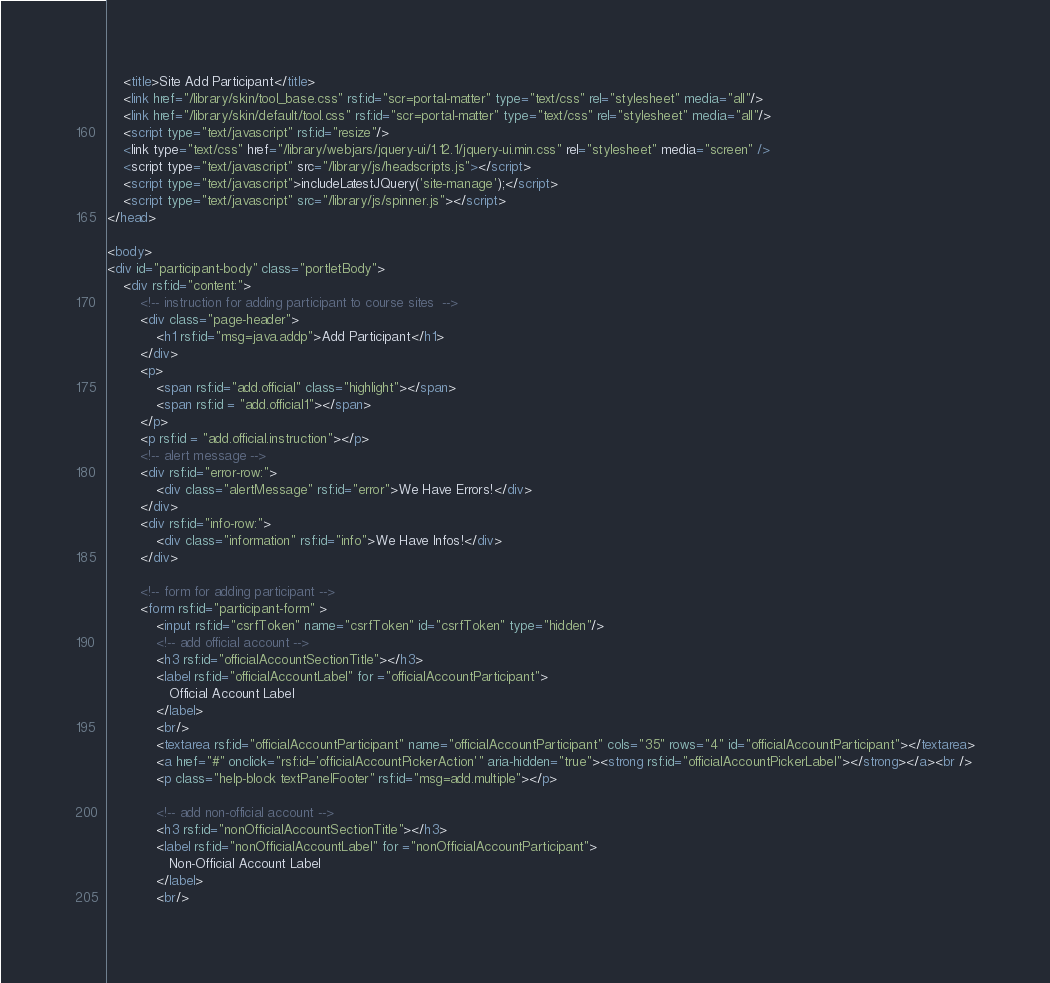<code> <loc_0><loc_0><loc_500><loc_500><_HTML_>	<title>Site Add Participant</title>
	<link href="/library/skin/tool_base.css" rsf:id="scr=portal-matter" type="text/css" rel="stylesheet" media="all"/>
	<link href="/library/skin/default/tool.css" rsf:id="scr=portal-matter" type="text/css" rel="stylesheet" media="all"/>
	<script type="text/javascript" rsf:id="resize"/>
	<link type="text/css" href="/library/webjars/jquery-ui/1.12.1/jquery-ui.min.css" rel="stylesheet" media="screen" />
	<script type="text/javascript" src="/library/js/headscripts.js"></script>
	<script type="text/javascript">includeLatestJQuery('site-manage');</script>
	<script type="text/javascript" src="/library/js/spinner.js"></script>
</head>

<body>
<div id="participant-body" class="portletBody">
	<div rsf:id="content:">
		<!-- instruction for adding participant to course sites  -->
		<div class="page-header">
			<h1 rsf:id="msg=java.addp">Add Participant</h1>
		</div>
		<p>
			<span rsf:id="add.official" class="highlight"></span>
			<span rsf:id = "add.official1"></span>
		</p>
		<p rsf:id = "add.official.instruction"></p>
		<!-- alert message -->
		<div rsf:id="error-row:">
			<div class="alertMessage" rsf:id="error">We Have Errors!</div>
		</div>
		<div rsf:id="info-row:">
			<div class="information" rsf:id="info">We Have Infos!</div>
		</div>

		<!-- form for adding participant -->
		<form rsf:id="participant-form" >
			<input rsf:id="csrfToken" name="csrfToken" id="csrfToken" type="hidden"/>
			<!-- add official account -->
			<h3 rsf:id="officialAccountSectionTitle"></h3>
			<label rsf:id="officialAccountLabel" for ="officialAccountParticipant">
	           Official Account Label
	        </label>
	        <br/>
	        <textarea rsf:id="officialAccountParticipant" name="officialAccountParticipant" cols="35" rows="4" id="officialAccountParticipant"></textarea>
			<a href="#" onclick="rsf:id='officialAccountPickerAction'" aria-hidden="true"><strong rsf:id="officialAccountPickerLabel"></strong></a><br />
			<p class="help-block textPanelFooter" rsf:id="msg=add.multiple"></p>
			
			<!-- add non-official account -->
			<h3 rsf:id="nonOfficialAccountSectionTitle"></h3>
			<label rsf:id="nonOfficialAccountLabel" for ="nonOfficialAccountParticipant">
	           Non-Official Account Label
	        </label>
	        <br/></code> 